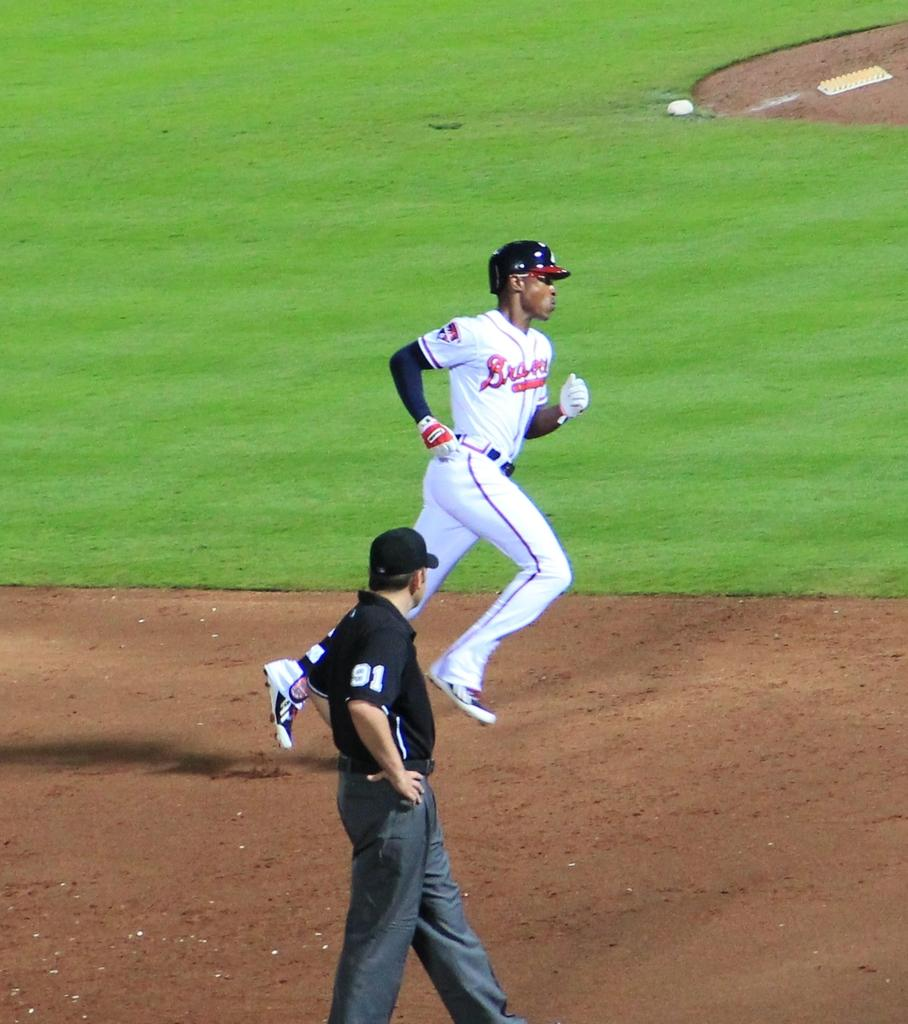Provide a one-sentence caption for the provided image. A player from the baseball team called the Braves. 